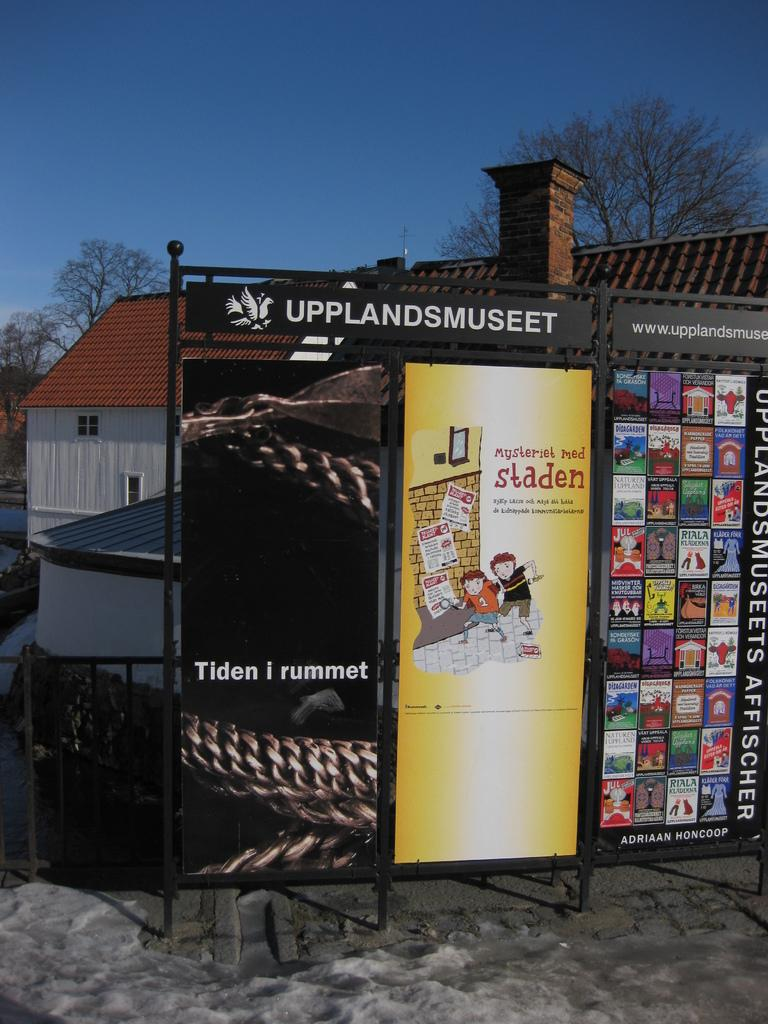<image>
Present a compact description of the photo's key features. a metal signboard with adverts saying UPPLANDSMUSEET, Tiden i yummet, staden and lots more. 